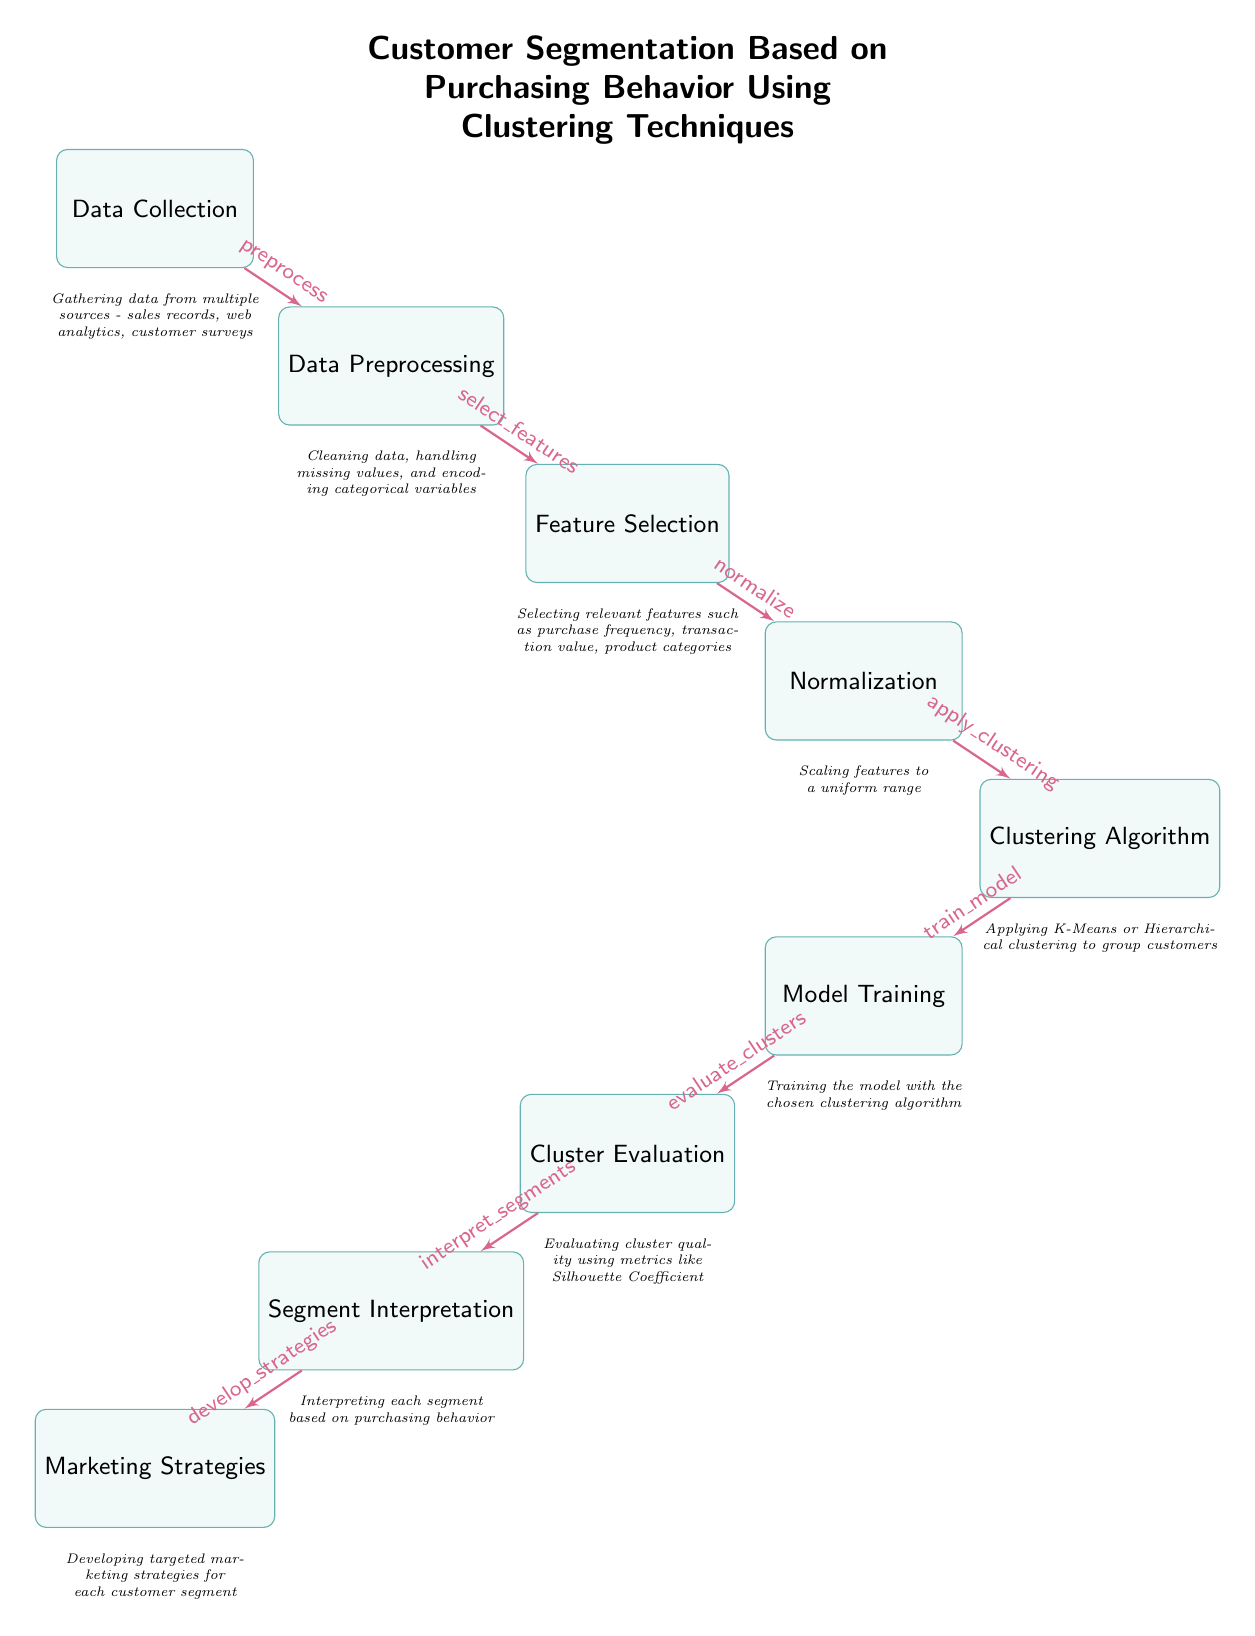What is the first step in the process? The diagram begins with the node "Data Collection," which indicates the first action taken in the customer segmentation process.
Answer: Data Collection How many nodes are present in the diagram? By counting the visible boxes in the diagram, there are nine distinct nodes representing steps in the process.
Answer: Nine What follows "Data Preprocessing" in the flow? The diagram shows an arrow leading from "Data Preprocessing" to "Feature Selection," indicating that feature selection is the subsequent step.
Answer: Feature Selection What clustering algorithms are mentioned? In the "Clustering Algorithm" node, it suggests applying K-Means or Hierarchical clustering, which are specific examples of clustering algorithms.
Answer: K-Means, Hierarchical clustering Which node evaluates clusters? The node labeled "Cluster Evaluation" is responsible for assessing the quality and effectiveness of the clusters formed through the algorithm used in the previous step.
Answer: Cluster Evaluation What are the last two steps in order? From the diagram, the last two steps proceed from "Segment Interpretation" to "Marketing Strategies," indicating the final decision-making based on the interpreted segments.
Answer: Segment Interpretation, Marketing Strategies Which step involves handling missing values? The process of handling missing values is part of the "Data Preprocessing" step, which includes cleaning the data to prepare it for the analysis.
Answer: Data Preprocessing What method is used to assess cluster quality? The "Cluster Evaluation" node specifies that metrics like the Silhouette Coefficient are utilized to gauge the quality of the formed clusters.
Answer: Silhouette Coefficient 